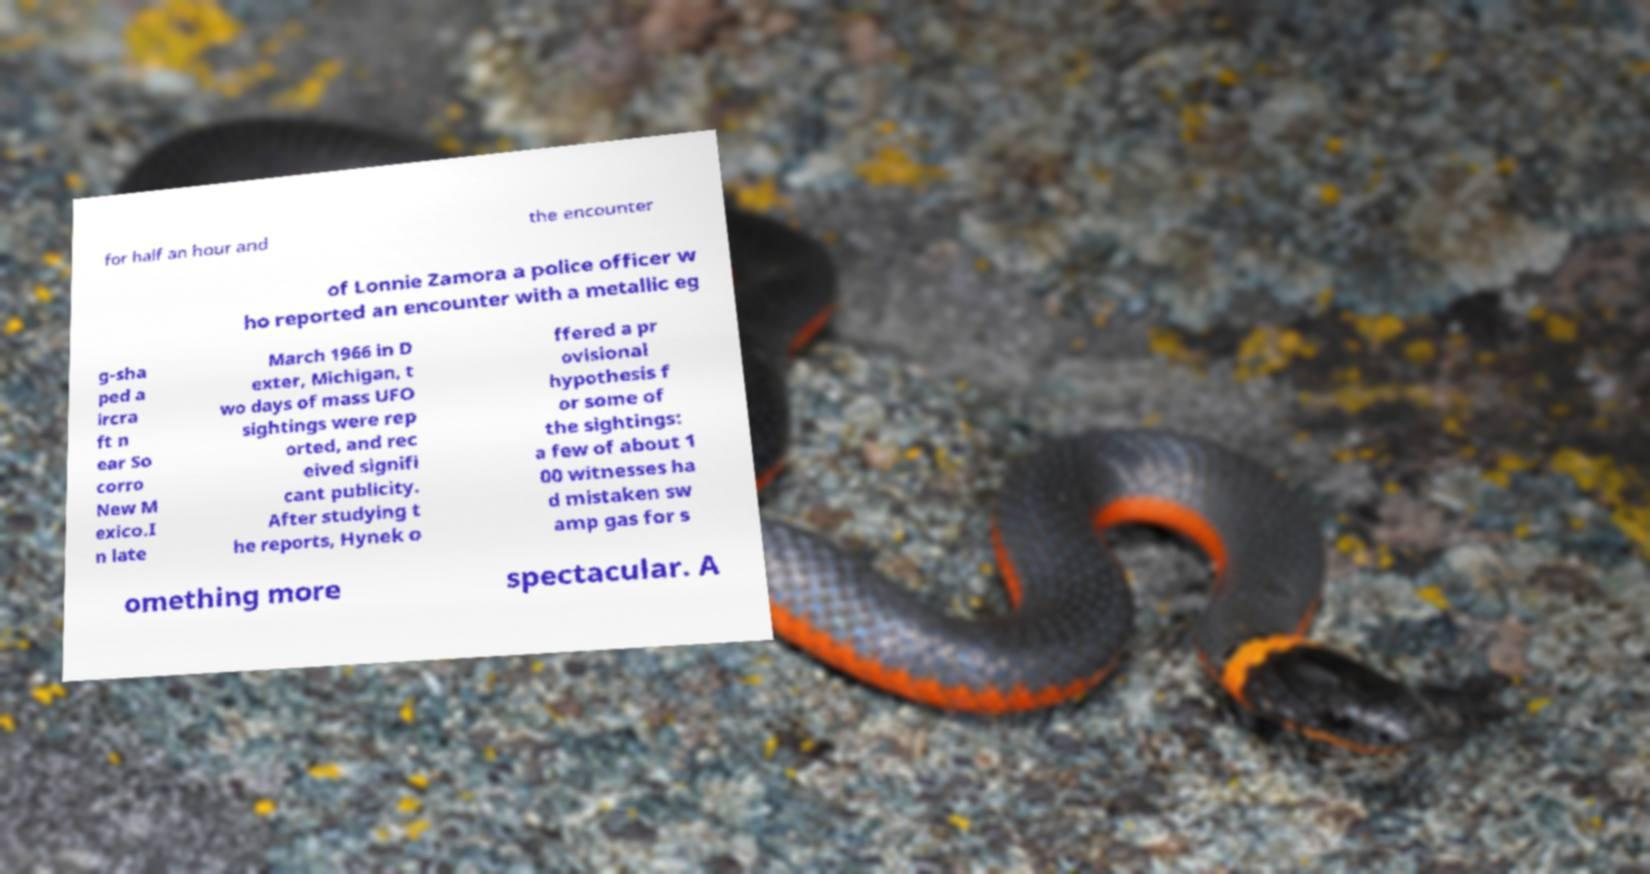Could you extract and type out the text from this image? for half an hour and the encounter of Lonnie Zamora a police officer w ho reported an encounter with a metallic eg g-sha ped a ircra ft n ear So corro New M exico.I n late March 1966 in D exter, Michigan, t wo days of mass UFO sightings were rep orted, and rec eived signifi cant publicity. After studying t he reports, Hynek o ffered a pr ovisional hypothesis f or some of the sightings: a few of about 1 00 witnesses ha d mistaken sw amp gas for s omething more spectacular. A 